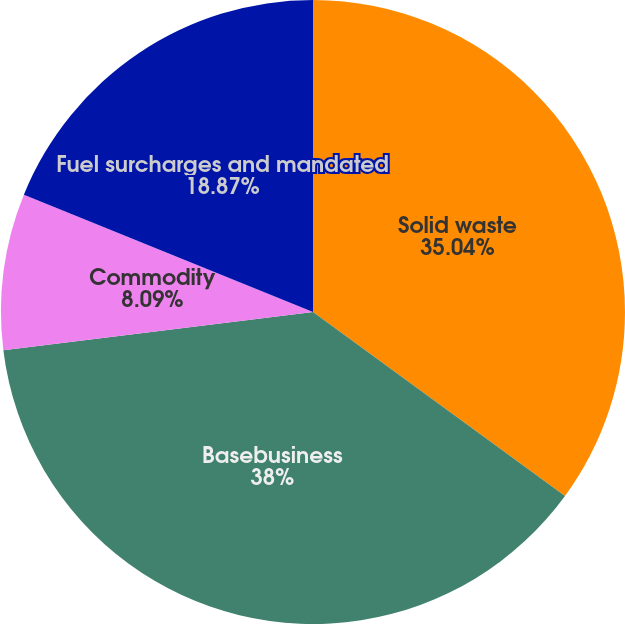Convert chart. <chart><loc_0><loc_0><loc_500><loc_500><pie_chart><fcel>Solid waste<fcel>Basebusiness<fcel>Commodity<fcel>Fuel surcharges and mandated<nl><fcel>35.04%<fcel>38.01%<fcel>8.09%<fcel>18.87%<nl></chart> 